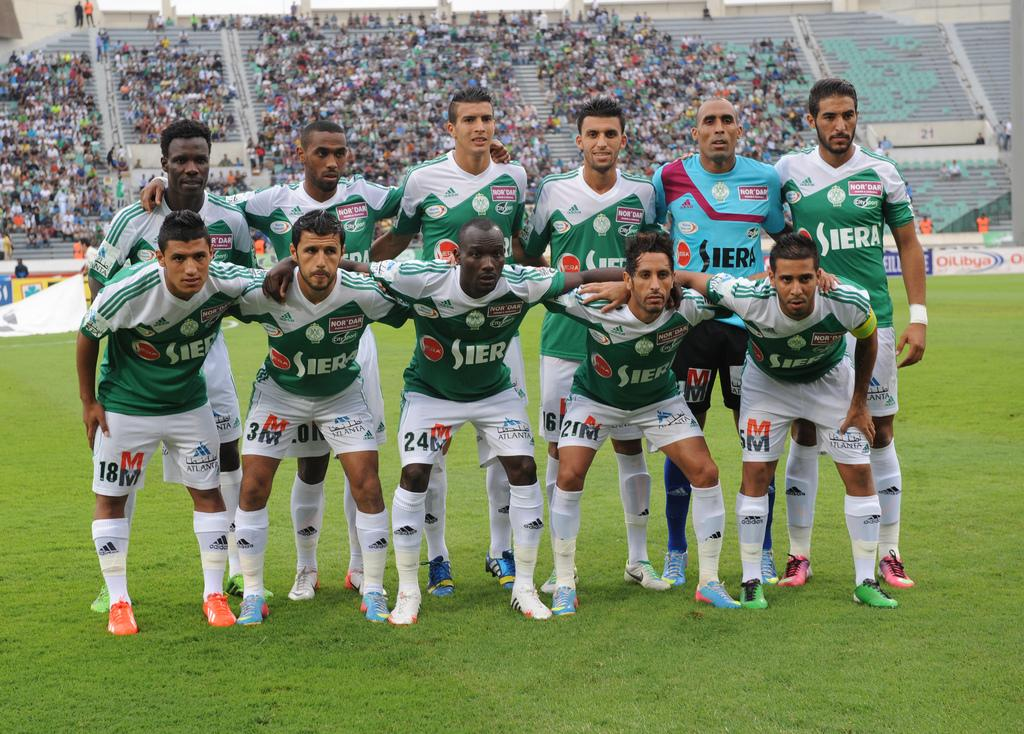<image>
Present a compact description of the photo's key features. players for siera lined up in 2 rows on field 